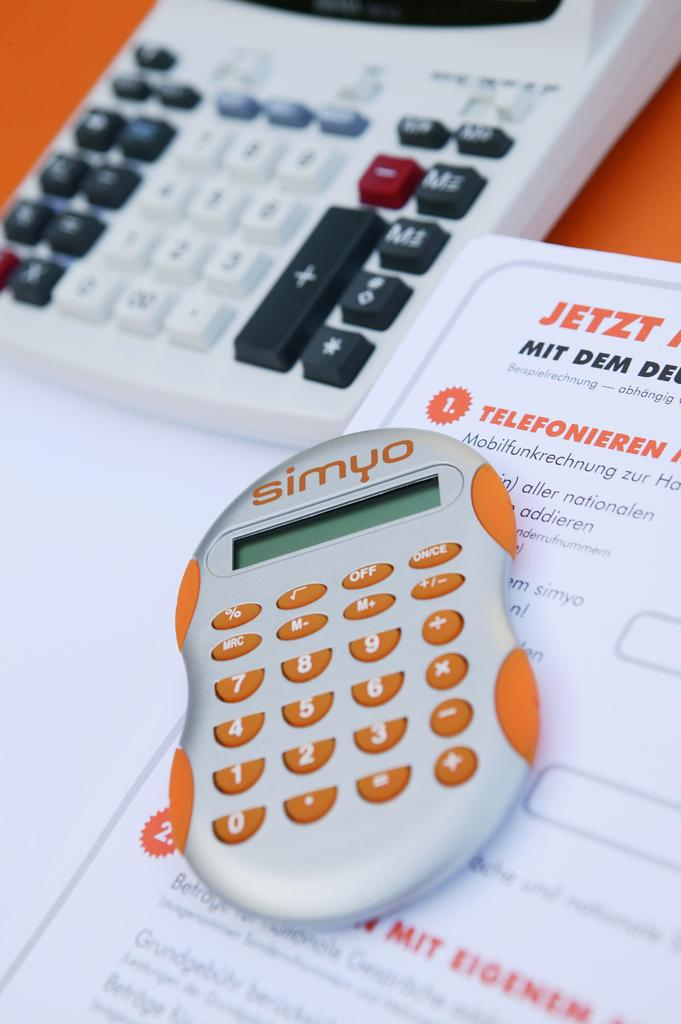Provide a one-sentence caption for the provided image. A Simyo calculator in front of German words like "Jetzt" and a larger calculator. 